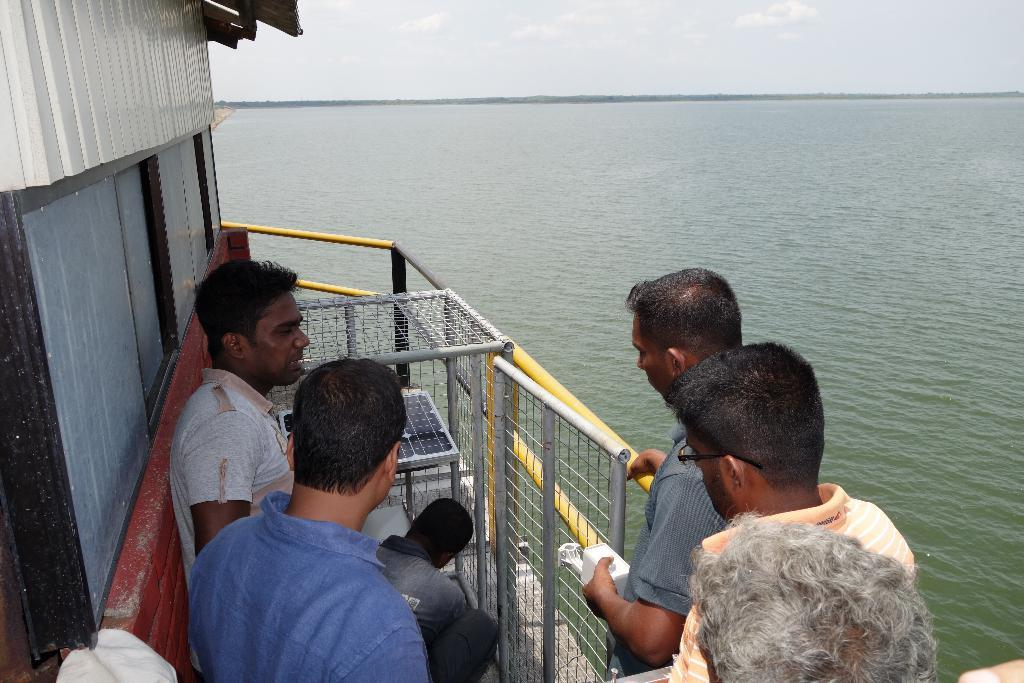Who or what can be seen in the image? There are people in the image. What type of objects are visible in the image? There are metal objects in the image. What kind of barrier is present in the image? There is a fence in the image. What is on the left side of the image? There is a wall on the left side of the image. What natural element is visible in the image? Water is visible in the image. What is visible in the background of the image? The sky is visible in the image, and clouds are present in the sky. What type of stew is being served on the plate in the image? There is no plate or stew present in the image. 